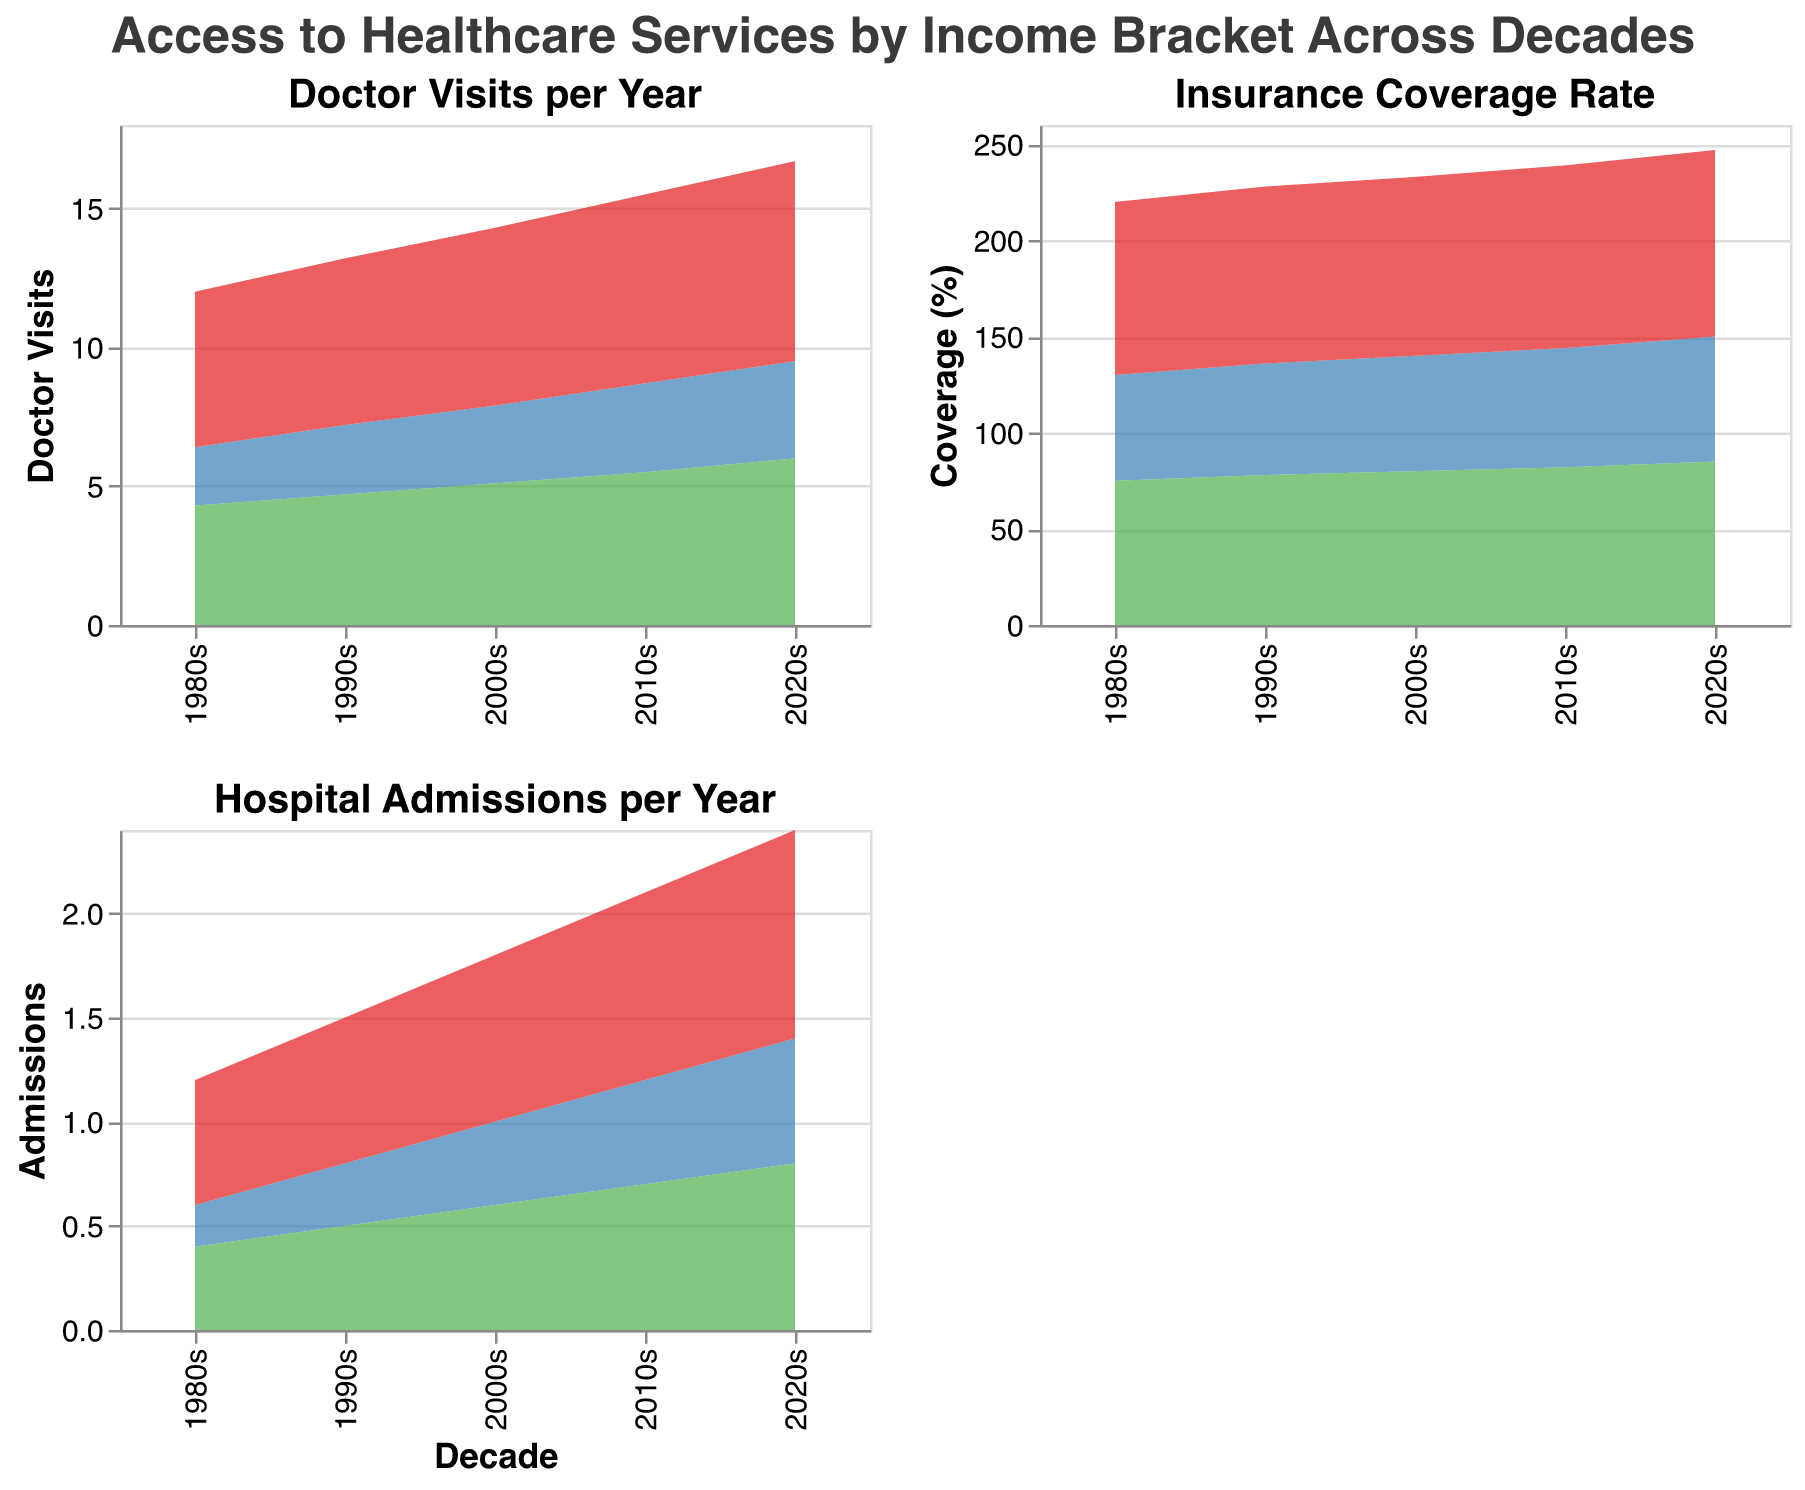What is the trend in doctor visits per year for the low-income bracket from the 1980s to the 2020s? Looking at the area chart for Doctor Visits per Year, the low-income bracket shows an increasing trend from 2.1 visits in the 1980s to 3.5 visits in the 2020s.
Answer: Increasing In which decade did the high-income bracket have the highest insurance coverage rate? Referring to the Insurance Coverage Rate chart, the high-income bracket has the highest coverage rate of 97% in the 2020s.
Answer: 2020s How does the number of hospital admissions per year for middle-income individuals in the 2010s compare to that in the 1980s? By comparing the corresponding points in the chart for Hospital Admissions per Year, middle-income individuals had 0.7 admissions in the 2010s and 0.4 admissions in the 1980s. 0.7 is greater than 0.4, thus it’s higher.
Answer: Higher What is the difference in hospital admissions per year between the high-income bracket and low-income bracket in the 2020s? On the Hospital Admissions per Year chart, the high-income had 1.0 admissions and the low-income had 0.6 admissions in the 2020s. The difference is 1.0 - 0.6 = 0.4 admissions.
Answer: 0.4 Which income bracket shows the smallest increase in doctor visits per year from the 1980s to the 2020s? Comparing the values for each income bracket in Doctor Visits per Year chart:
- Low income: 3.5 - 2.1 = 1.4 increase
- Middle income: 6.0 - 4.3 = 1.7 increase
- High income: 7.2 - 5.6 = 1.6 increase
Low-income bracket shows the smallest increase of 1.4.
Answer: Low income Does the insurance coverage rate consistently increase for all income brackets over the decades? Observing the sequences for each income bracket in the Insurance Coverage Rate chart, all brackets (low, middle, high) show a consistent increase in coverage rate from the 1980s to the 2020s.
Answer: Yes By how much did the doctor visits per year increase for middle-income individuals from the 1990s to the 2000s? On the Doctor Visits per Year chart, middle-income individuals had 4.7 visits in the 1990s and 5.1 visits in the 2000s. The increase is 5.1 - 4.7 = 0.4 visits.
Answer: 0.4 Which decade shows the highest hospital admissions per year for low-income individuals? In the Hospital Admissions per Year chart, the highest hospital admissions for the low-income bracket are 0.6 in the 2020s.
Answer: 2020s 